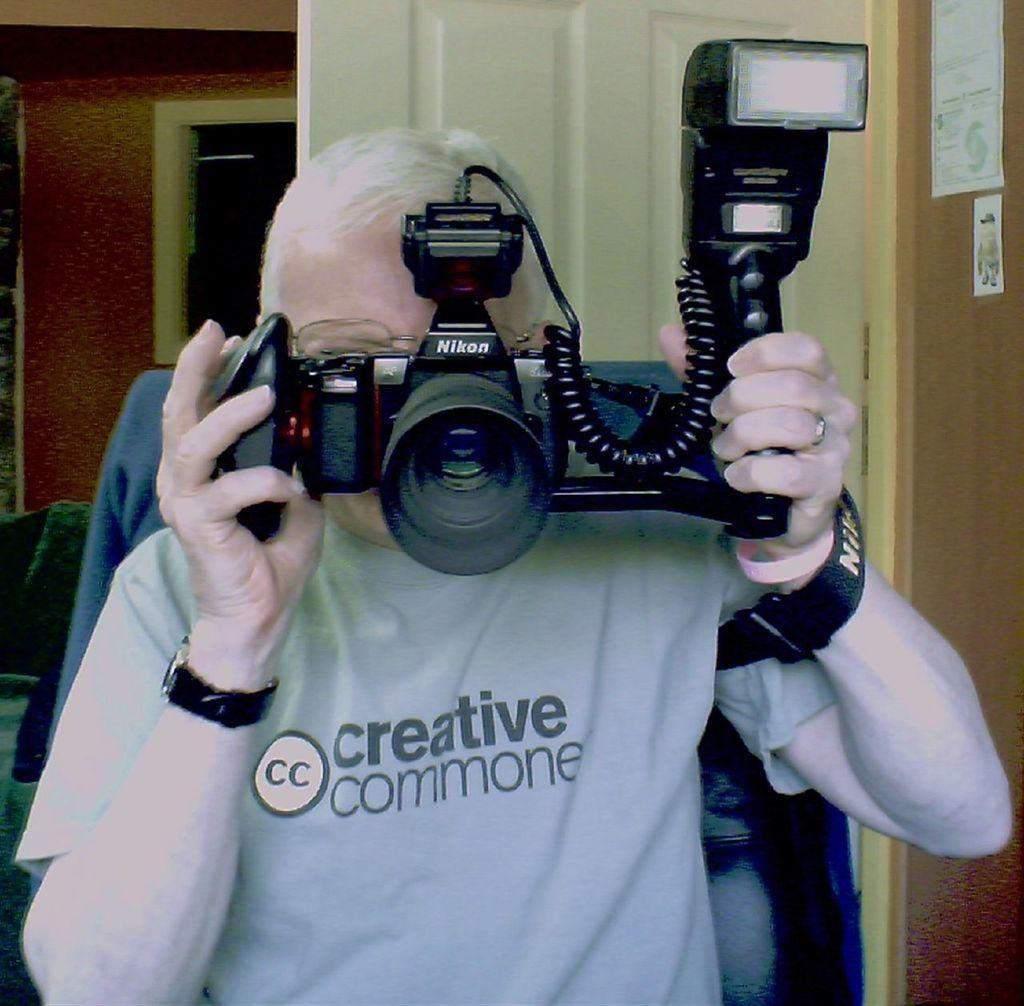What is one of the architectural features visible in the image? There is a door in the image. What color is the wall in the image? The wall in the image is red. What can be seen in the image that allows natural light to enter the room? There is a window in the image. What object is present in the image that might be used for writing or drawing? There is a paper in the image. What is the man in the image doing? The man is sitting on a chair in the image. What is the man holding in the image? The man is holding a camera in the image. How many oranges are on the table in the image? There are no oranges present in the image. What type of crime is being committed in the image? There is no crime being committed in the image; it features a man sitting on a chair holding a camera. 